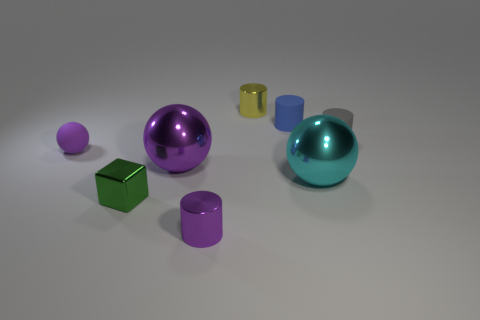There is a tiny green shiny block on the left side of the shiny cylinder that is in front of the big cyan sphere; are there any small metal things that are in front of it? While the image depicts a variety of objects, including a shiny green block and a shiny cylinder positioned in front of a large cyan sphere, there are no small metal objects in front of the mentioned cylinder. 